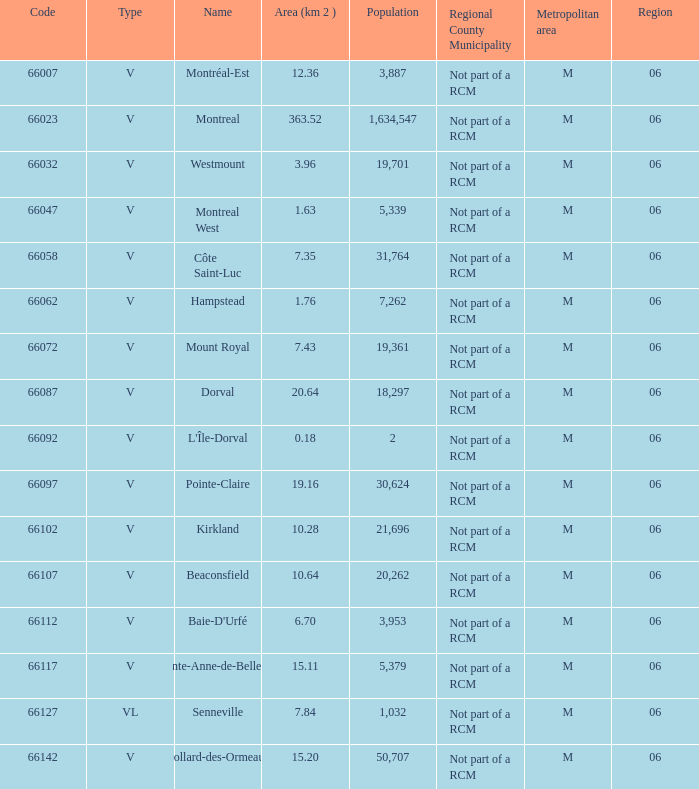What is the largest region with a Code smaller than 66112, and a Name of l'île-dorval? 6.0. 